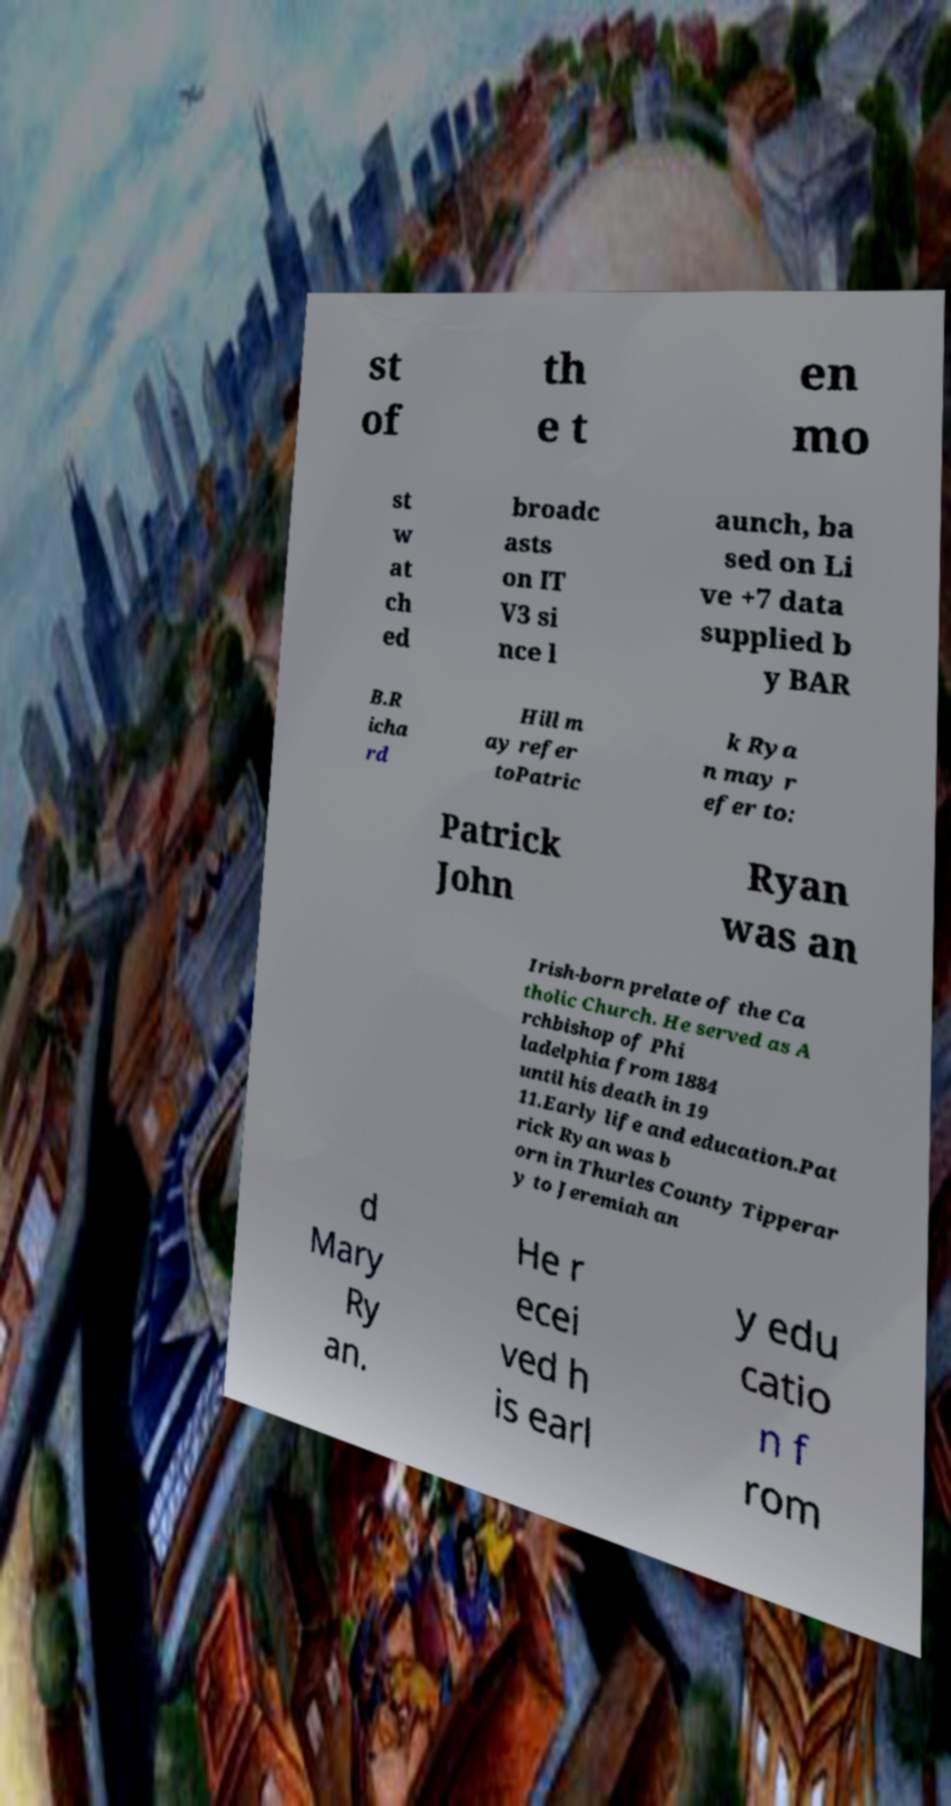Could you assist in decoding the text presented in this image and type it out clearly? st of th e t en mo st w at ch ed broadc asts on IT V3 si nce l aunch, ba sed on Li ve +7 data supplied b y BAR B.R icha rd Hill m ay refer toPatric k Rya n may r efer to: Patrick John Ryan was an Irish-born prelate of the Ca tholic Church. He served as A rchbishop of Phi ladelphia from 1884 until his death in 19 11.Early life and education.Pat rick Ryan was b orn in Thurles County Tipperar y to Jeremiah an d Mary Ry an. He r ecei ved h is earl y edu catio n f rom 